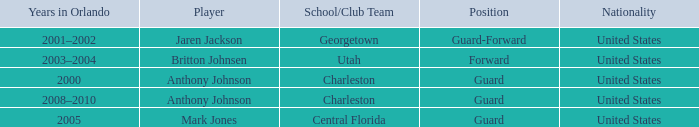What was the Position of the Player, Britton Johnsen? Forward. 